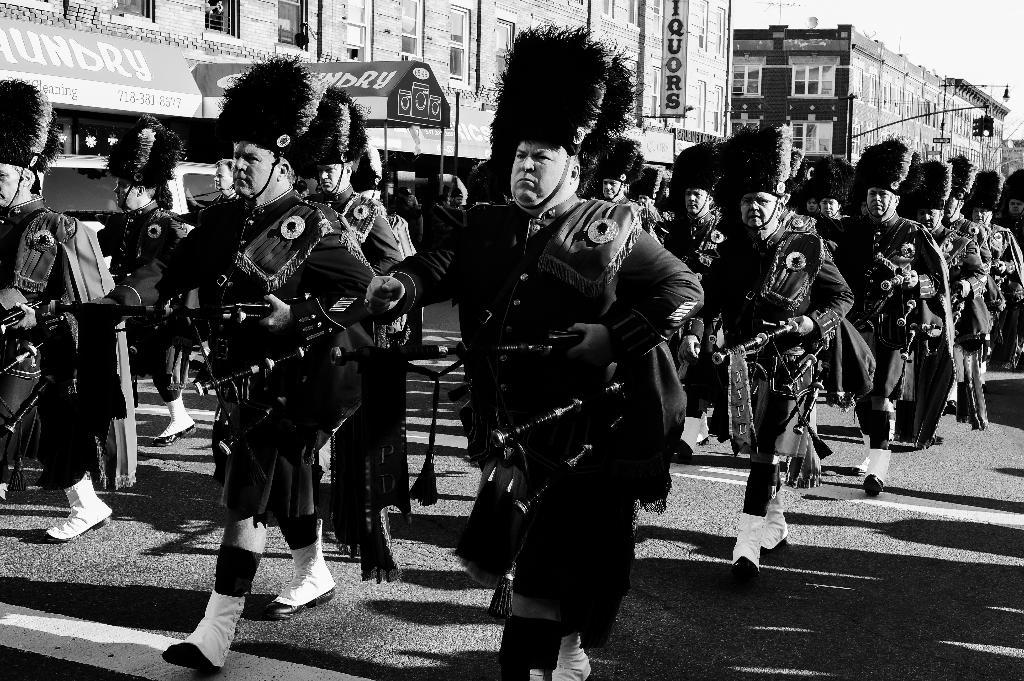What is the color scheme of the image? The image is black and white. What are the people in the image doing? There is a group of people walking on the road. What can be seen in the background of the image? There are buildings, stalls, banners, walls, windows, and people in the background. How many bulbs are hanging from the sky in the image? There are no bulbs present in the image, and the sky is not visible in the black and white image. What type of army is marching in the background of the image? There is no army present in the image; it features a group of people walking on the road and various elements in the background. 